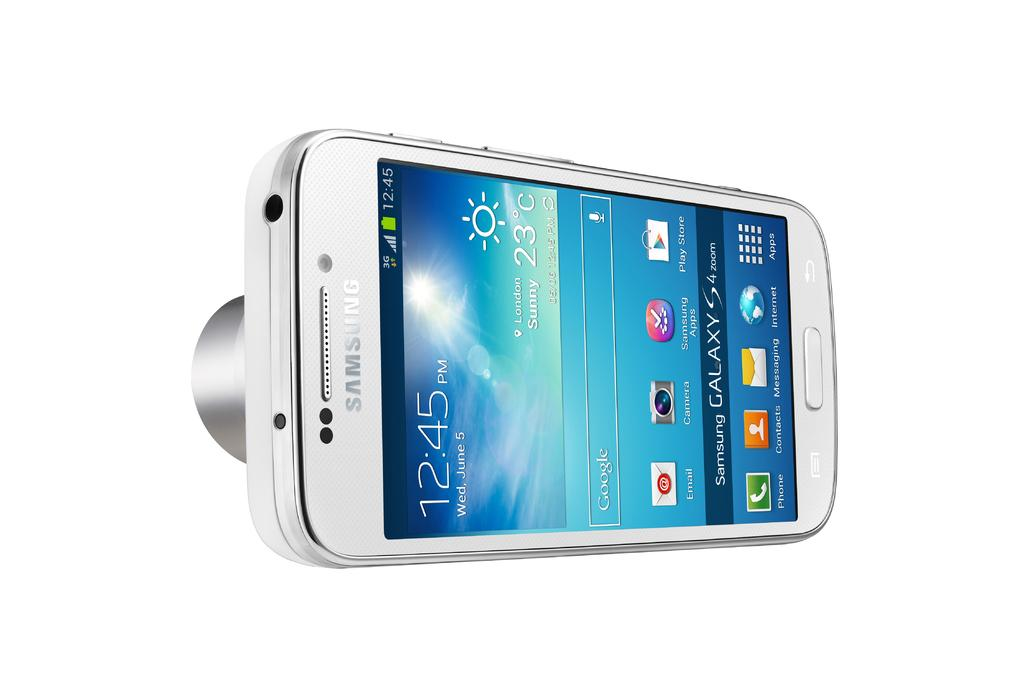<image>
Share a concise interpretation of the image provided. White samsung phone with apps on the home screen 